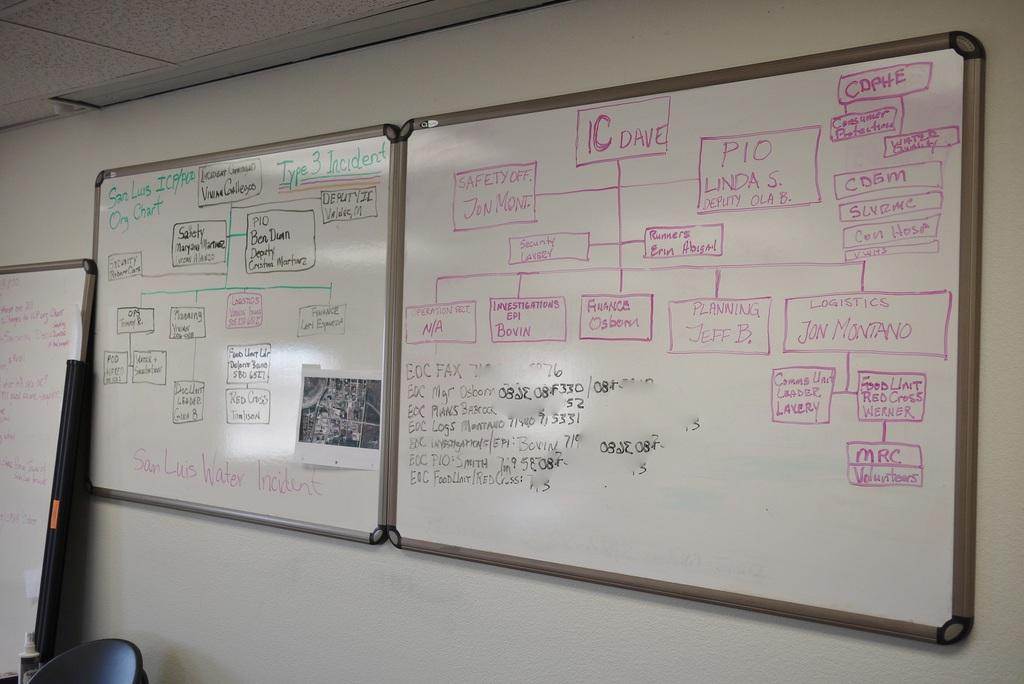What type of boards are visible in the image? There are white boards in the image. Where are the white boards located in the image? The white boards are attached to the wall. What is written on the white boards? There is text written on the white boards. Can you see an owl sitting on the throne in the image? There is no throne or owl present in the image. 